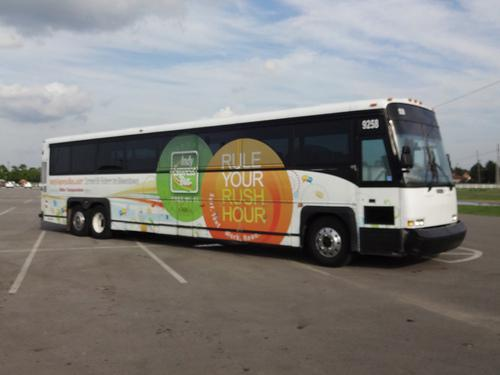Question: what color is the ground?
Choices:
A. Brown.
B. Black.
C. Grey.
D. Tan.
Answer with the letter. Answer: C Question: why is it a little dark?
Choices:
A. Sunset.
B. Dusk.
C. Not enough lighting.
D. Cloudy.
Answer with the letter. Answer: D Question: where is the bus parked?
Choices:
A. Parking garage.
B. Side of the road.
C. Lot.
D. The bus station.
Answer with the letter. Answer: C 